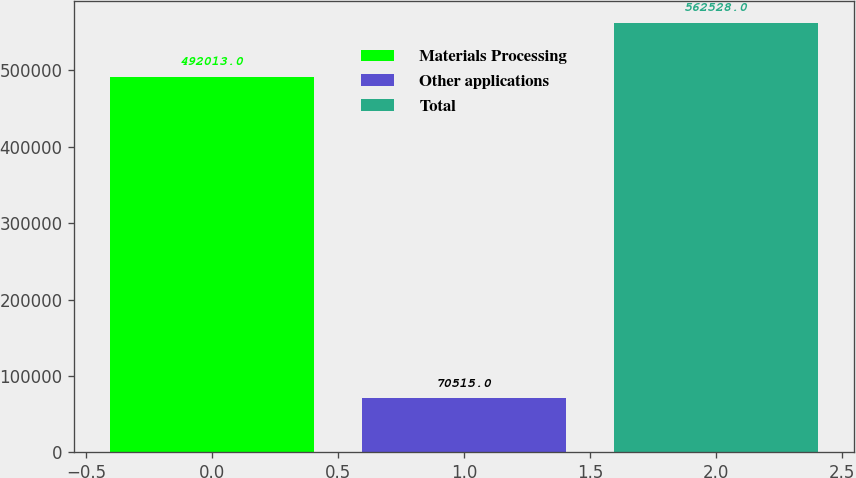Convert chart to OTSL. <chart><loc_0><loc_0><loc_500><loc_500><bar_chart><fcel>Materials Processing<fcel>Other applications<fcel>Total<nl><fcel>492013<fcel>70515<fcel>562528<nl></chart> 